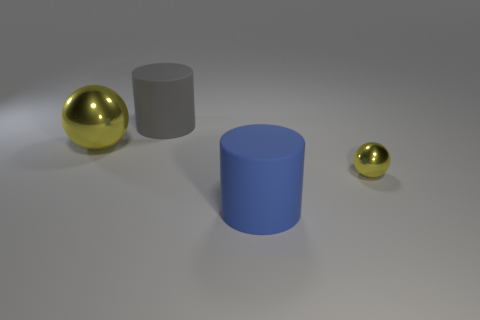There is a yellow object that is to the right of the rubber thing that is behind the small thing; what size is it?
Offer a terse response. Small. Is the small object the same color as the big metallic object?
Your answer should be very brief. Yes. How many matte objects are either large balls or green cylinders?
Provide a succinct answer. 0. How many rubber objects are there?
Provide a succinct answer. 2. Is the yellow ball left of the blue cylinder made of the same material as the sphere on the right side of the large gray matte cylinder?
Give a very brief answer. Yes. There is another large thing that is the same shape as the large blue object; what is its color?
Offer a terse response. Gray. What is the material of the big object right of the gray rubber thing to the left of the tiny metal ball?
Provide a short and direct response. Rubber. Does the shiny thing to the right of the big gray rubber cylinder have the same shape as the large thing that is in front of the small shiny thing?
Your answer should be very brief. No. There is a thing that is both left of the big blue object and in front of the gray cylinder; what size is it?
Keep it short and to the point. Large. How many other objects are the same color as the big ball?
Make the answer very short. 1. 